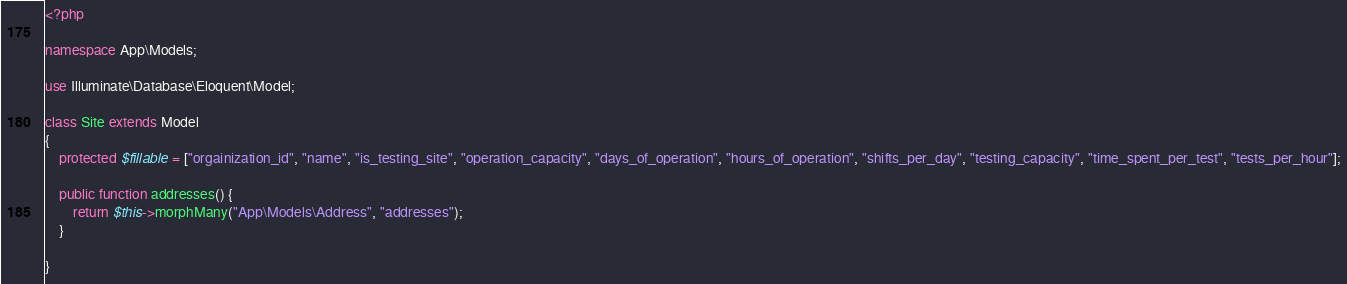<code> <loc_0><loc_0><loc_500><loc_500><_PHP_><?php

namespace App\Models;

use Illuminate\Database\Eloquent\Model;

class Site extends Model
{
    protected $fillable = ["orgainization_id", "name", "is_testing_site", "operation_capacity", "days_of_operation", "hours_of_operation", "shifts_per_day", "testing_capacity", "time_spent_per_test", "tests_per_hour"];

    public function addresses() {
        return $this->morphMany("App\Models\Address", "addresses");
    }

}
</code> 